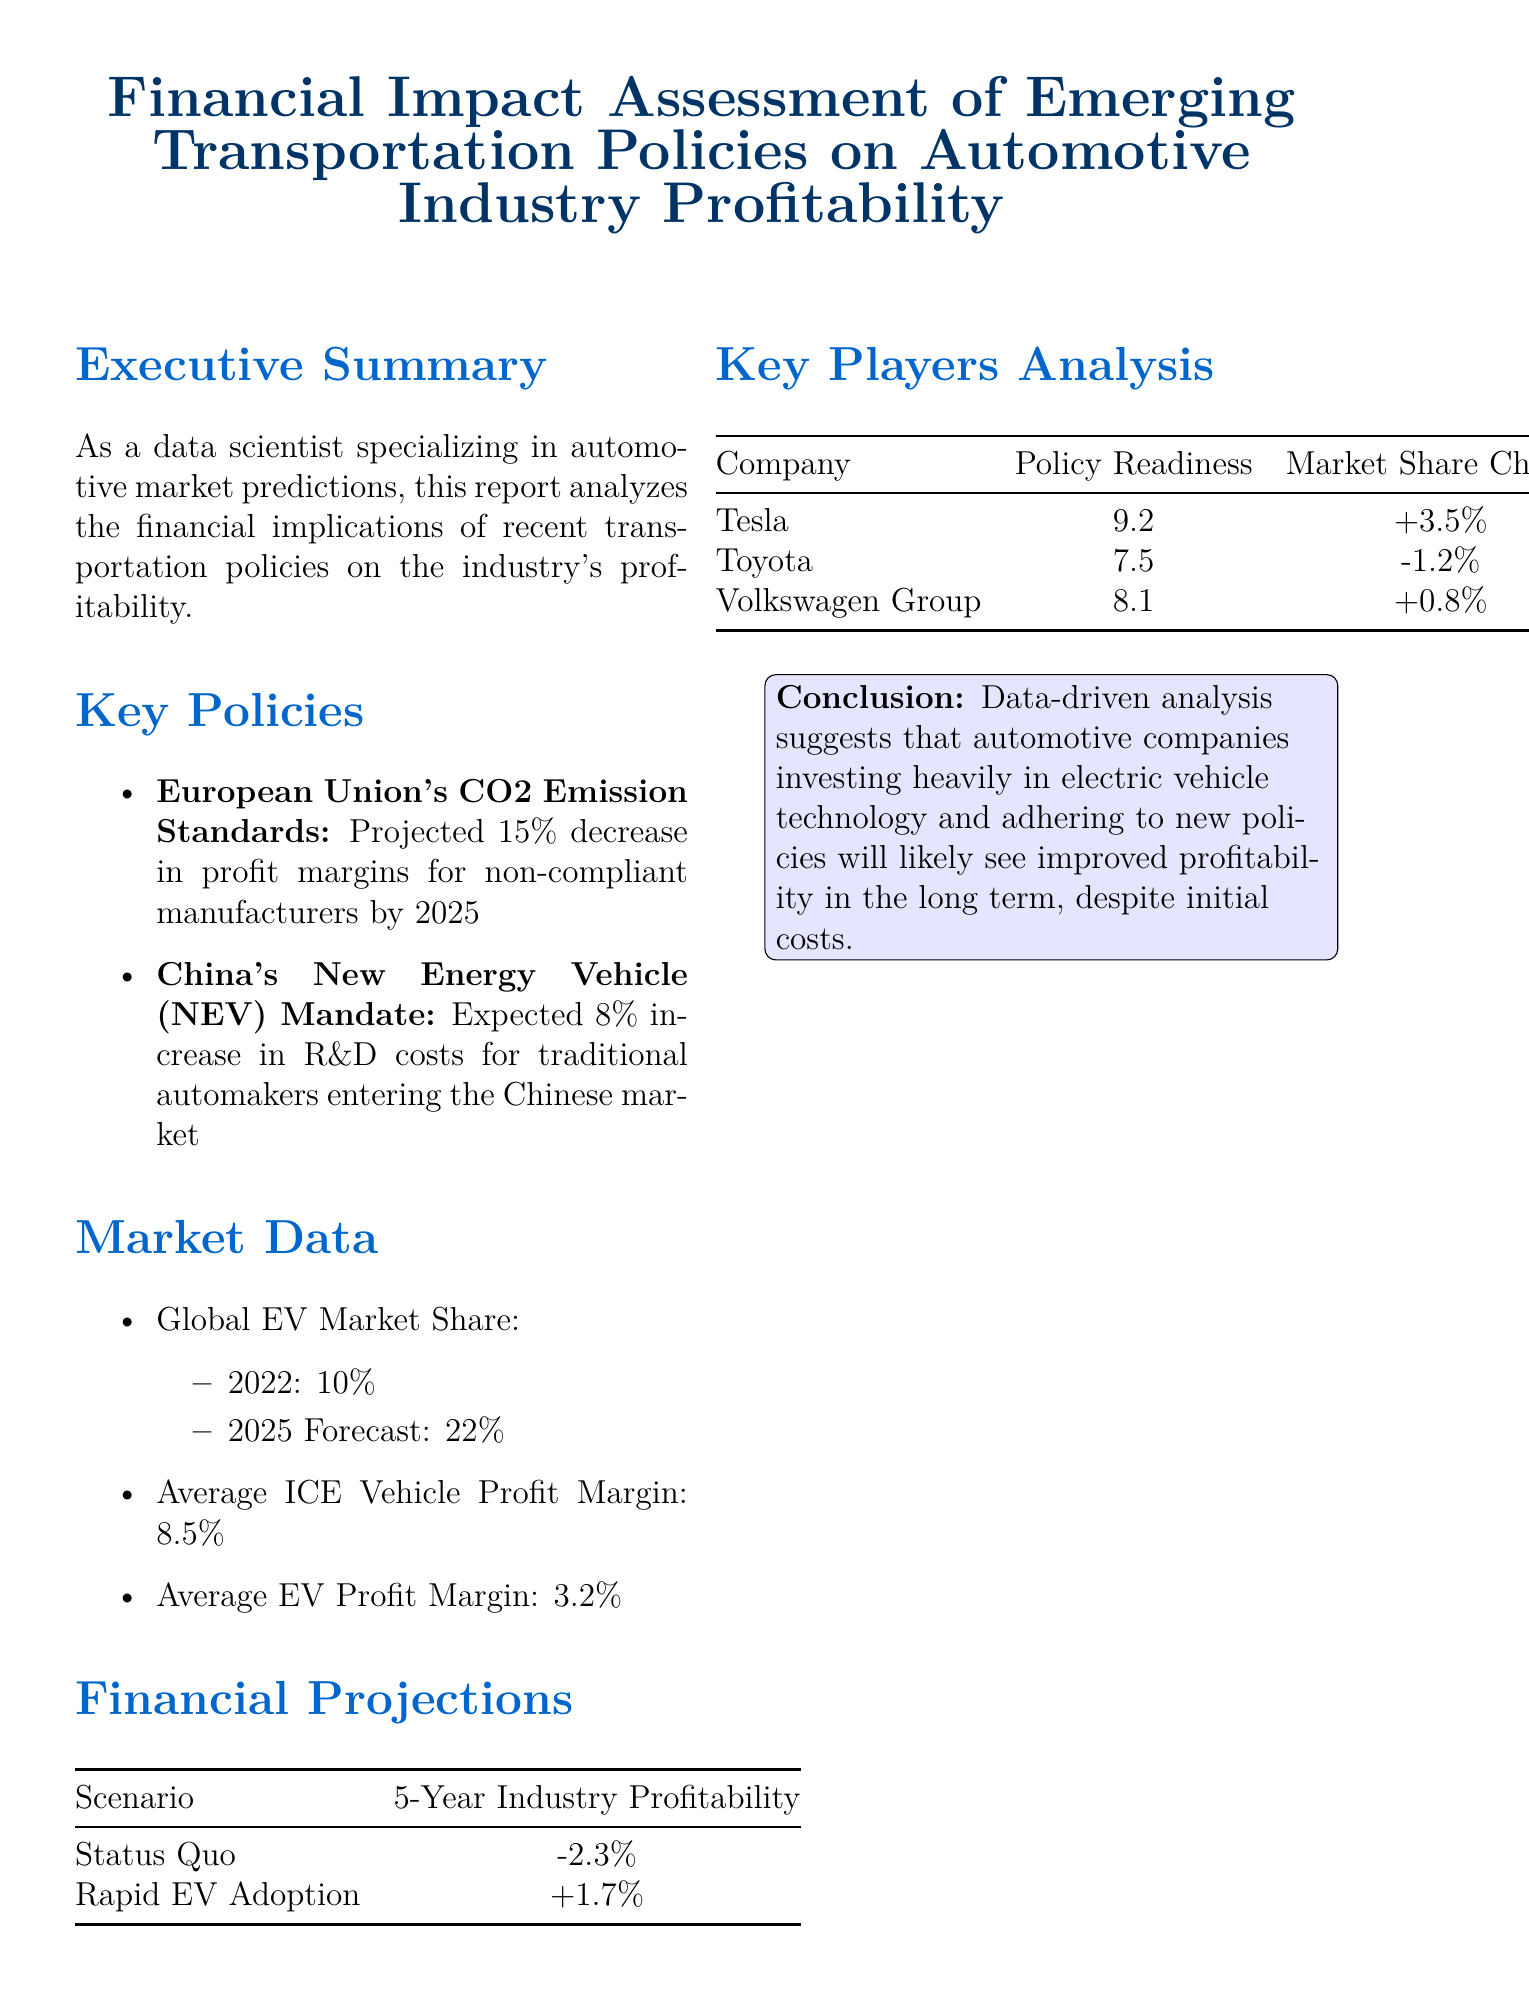What is the report title? The report title is presented at the beginning of the document, summarizing its focus on financial impact assessment related to the automotive industry.
Answer: Financial Impact Assessment of Emerging Transportation Policies on Automotive Industry Profitability What is the projected profit margin decrease for non-compliant manufacturers by 2025? The document states the impact of the European Union's CO2 Emission Standards, specifically the projected decrease in profit margins for non-compliant manufacturers.
Answer: 15% What is the expected increase in R&D costs for traditional automakers entering China? This refers to the financial impact of China's New Energy Vehicle (NEV) Mandate outlined in the key policies section.
Answer: 8% What is the average profit margin for ICE vehicles? This information is found in the market data section, detailing the average profit margins for different types of vehicles.
Answer: 8.5% What is the policy readiness score for Tesla? The key players analysis provides policy readiness scores for various companies, with Tesla having the highest score.
Answer: 9.2 In the status quo scenario, what is the projected 5-year industry profitability? The financial projections section lists profitability scenarios, detailing expected profitability under different conditions.
Answer: -2.3% What is the forecasted global EV market share for 2025? This statistic is found in the market data section, showcasing the growth of the electric vehicle market.
Answer: 22% What conclusion is drawn regarding companies investing in electric vehicle technology? The conclusion emphasizes the long-term financial outcomes for automotive companies making significant investments in EV technology.
Answer: Improved profitability in the long term 